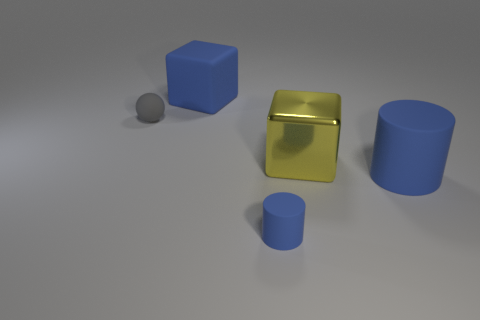Add 1 yellow metal cubes. How many objects exist? 6 Subtract all balls. How many objects are left? 4 Add 5 large yellow metallic balls. How many large yellow metallic balls exist? 5 Subtract 0 purple spheres. How many objects are left? 5 Subtract all red metallic cylinders. Subtract all big yellow objects. How many objects are left? 4 Add 5 large blue blocks. How many large blue blocks are left? 6 